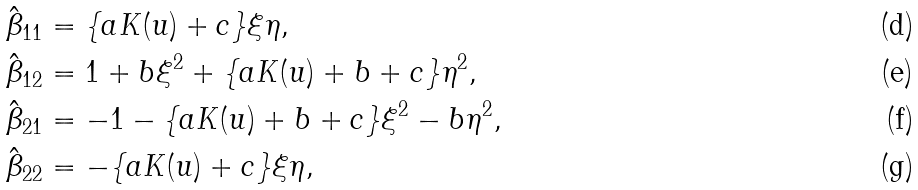<formula> <loc_0><loc_0><loc_500><loc_500>\hat { \beta } _ { 1 1 } & = \{ a K ( u ) + c \} \xi \eta , \\ \hat { \beta } _ { 1 2 } & = 1 + b \xi ^ { 2 } + \{ a K ( u ) + b + c \} \eta ^ { 2 } , \\ \hat { \beta } _ { 2 1 } & = - 1 - \{ a K ( u ) + b + c \} \xi ^ { 2 } - b \eta ^ { 2 } , \\ \hat { \beta } _ { 2 2 } & = - \{ a K ( u ) + c \} \xi \eta ,</formula> 